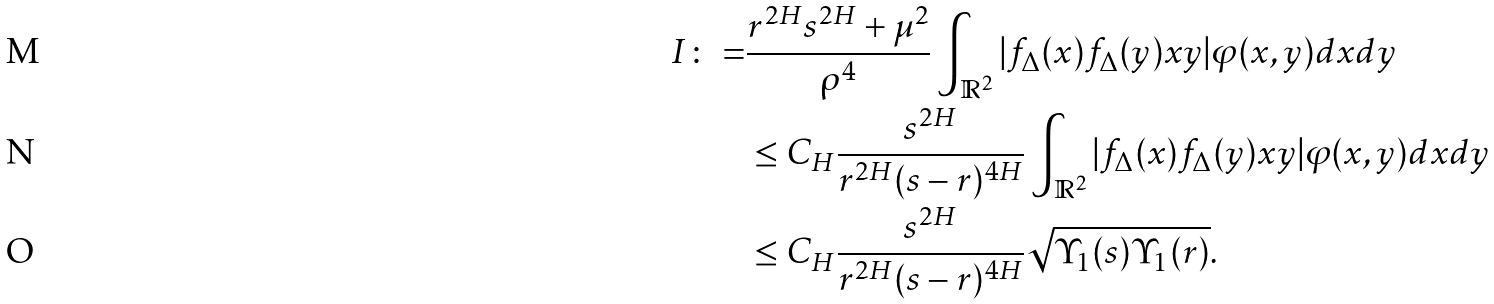<formula> <loc_0><loc_0><loc_500><loc_500>I \colon = & \frac { r ^ { 2 H } s ^ { 2 H } + \mu ^ { 2 } } { \rho ^ { 4 } } \int _ { \mathbb { R } ^ { 2 } } | f _ { \Delta } ( x ) f _ { \Delta } ( y ) x y | \varphi ( x , y ) d x d y \\ & \leq C _ { H } \frac { s ^ { 2 H } } { r ^ { 2 H } ( s - r ) ^ { 4 H } } \int _ { \mathbb { R } ^ { 2 } } | f _ { \Delta } ( x ) f _ { \Delta } ( y ) x y | \varphi ( x , y ) d x d y \\ & \leq C _ { H } \frac { s ^ { 2 H } } { r ^ { 2 H } ( s - r ) ^ { 4 H } } \sqrt { \Upsilon _ { 1 } ( s ) \Upsilon _ { 1 } ( r ) } .</formula> 